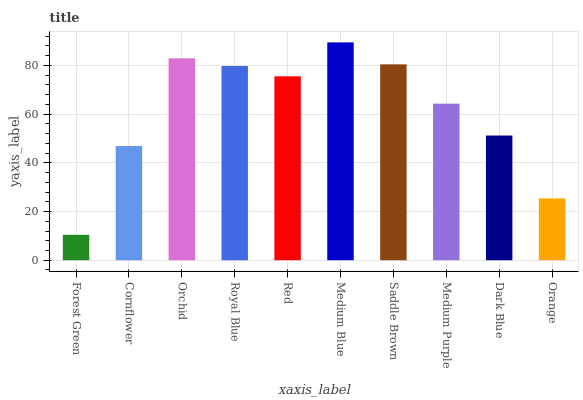Is Cornflower the minimum?
Answer yes or no. No. Is Cornflower the maximum?
Answer yes or no. No. Is Cornflower greater than Forest Green?
Answer yes or no. Yes. Is Forest Green less than Cornflower?
Answer yes or no. Yes. Is Forest Green greater than Cornflower?
Answer yes or no. No. Is Cornflower less than Forest Green?
Answer yes or no. No. Is Red the high median?
Answer yes or no. Yes. Is Medium Purple the low median?
Answer yes or no. Yes. Is Medium Purple the high median?
Answer yes or no. No. Is Orange the low median?
Answer yes or no. No. 